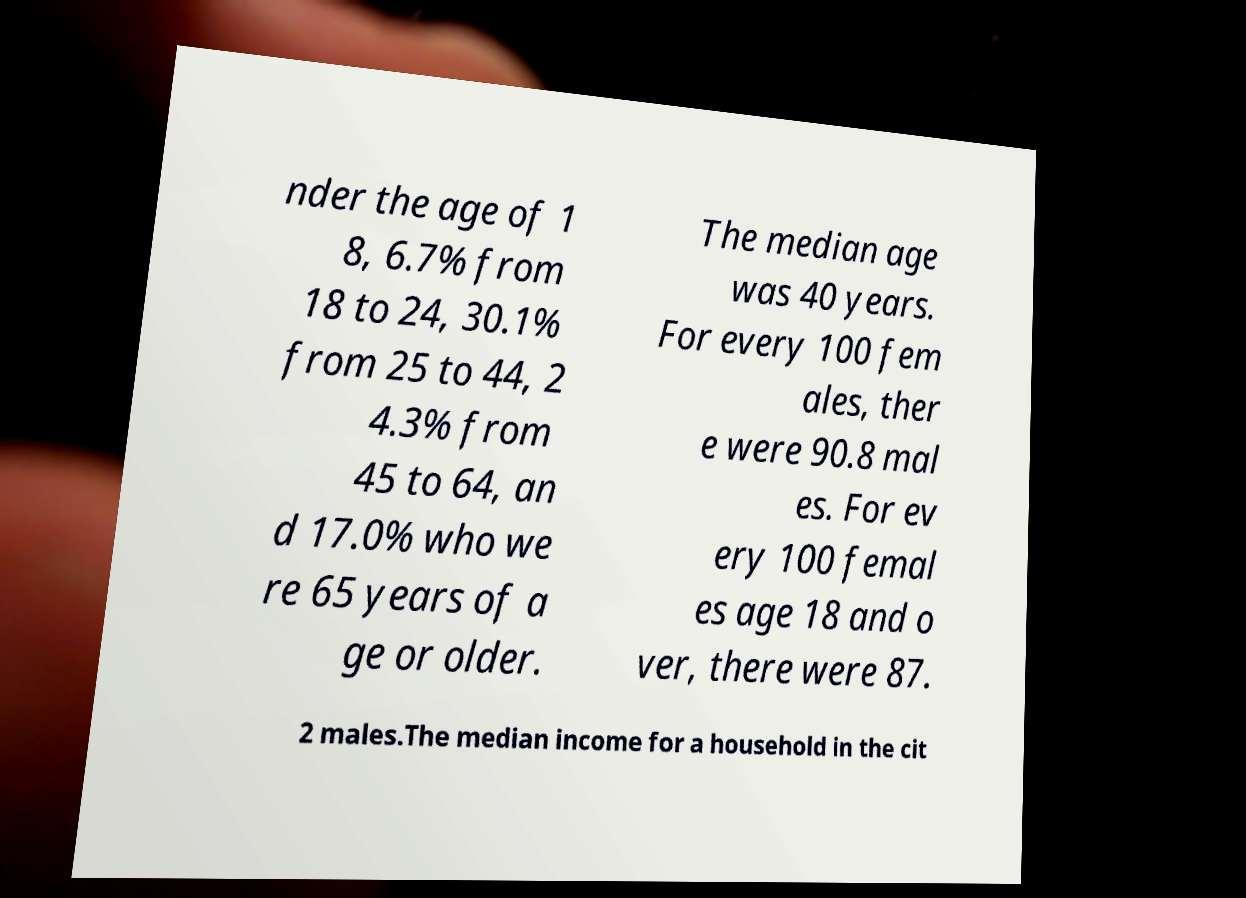Can you accurately transcribe the text from the provided image for me? nder the age of 1 8, 6.7% from 18 to 24, 30.1% from 25 to 44, 2 4.3% from 45 to 64, an d 17.0% who we re 65 years of a ge or older. The median age was 40 years. For every 100 fem ales, ther e were 90.8 mal es. For ev ery 100 femal es age 18 and o ver, there were 87. 2 males.The median income for a household in the cit 